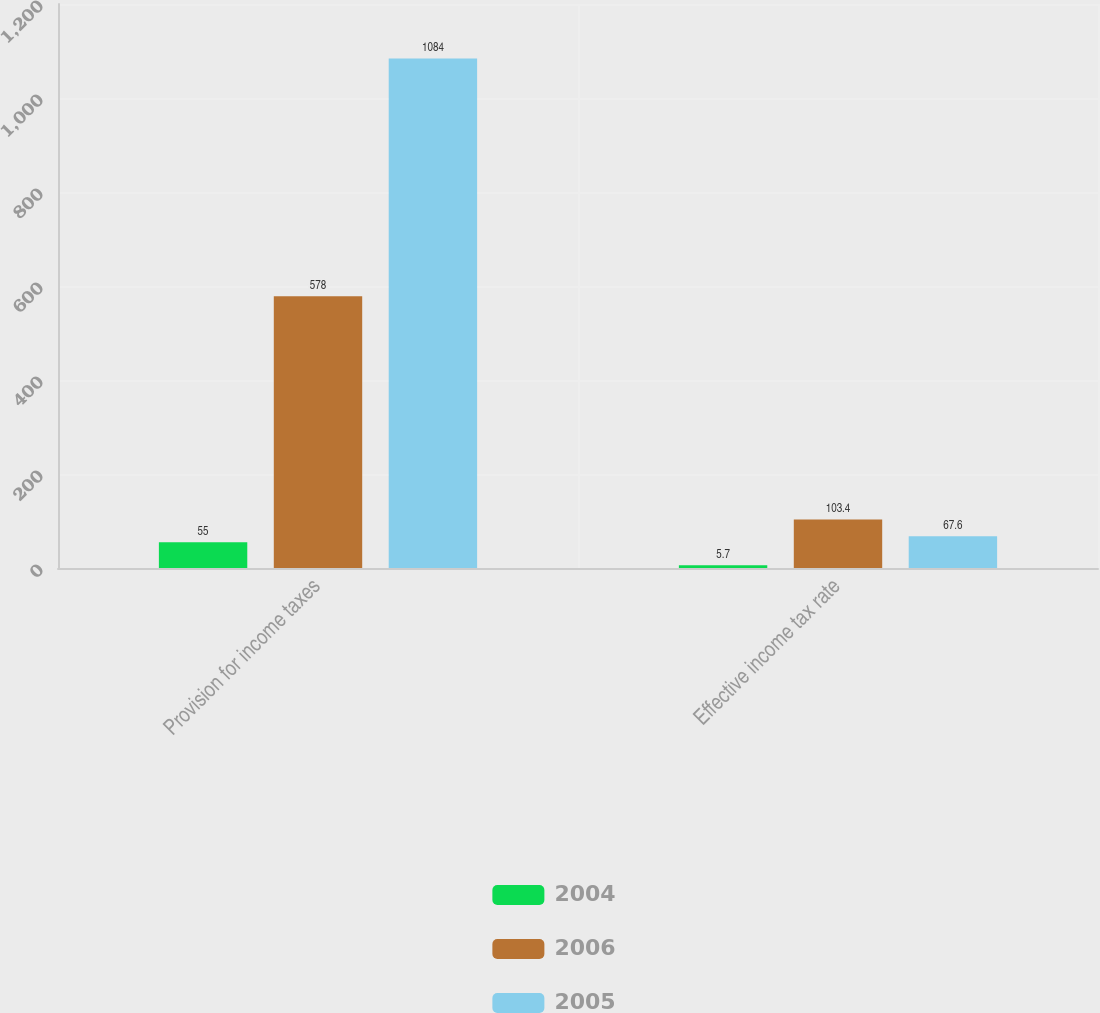<chart> <loc_0><loc_0><loc_500><loc_500><stacked_bar_chart><ecel><fcel>Provision for income taxes<fcel>Effective income tax rate<nl><fcel>2004<fcel>55<fcel>5.7<nl><fcel>2006<fcel>578<fcel>103.4<nl><fcel>2005<fcel>1084<fcel>67.6<nl></chart> 